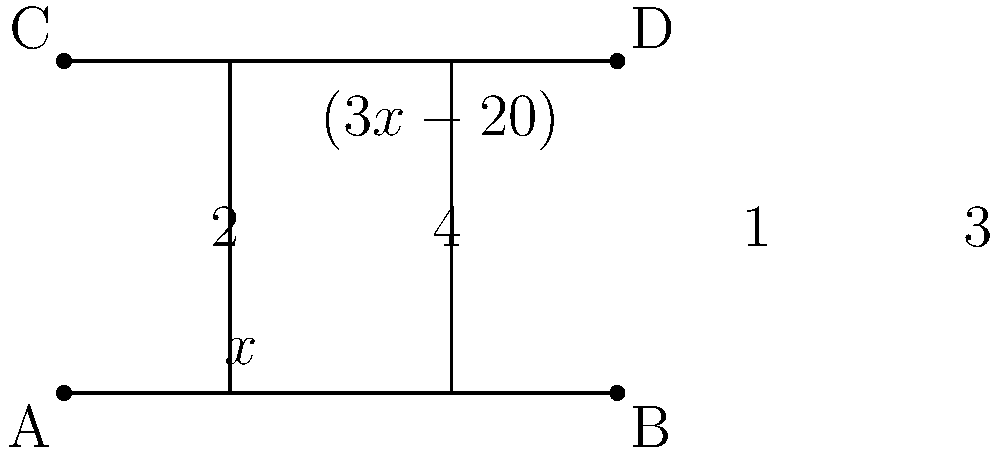In the figure above, lines AB and CD are parallel, and they are intersected by two transversals EF and GH. Given that angle 1 measures $x°$ and angle 4 measures $(3x-20)°$, determine the value of $x$. To solve this problem, let's follow these steps:

1) First, recall that when parallel lines are cut by a transversal, corresponding angles are congruent. This means:
   - Angle 1 = Angle 3
   - Angle 2 = Angle 4

2) We're given that:
   - Angle 1 = $x°$
   - Angle 4 = $(3x-20)°$

3) Since Angle 2 and Angle 4 form a linear pair (they're on the same line), they must sum to 180°:
   Angle 2 + Angle 4 = 180°

4) We know Angle 2 = Angle 1 = $x°$, so we can substitute:
   $x° + (3x-20)° = 180°$

5) Now we can solve this equation:
   $x + 3x - 20 = 180$
   $4x - 20 = 180$
   $4x = 200$
   $x = 50$

6) To verify, let's check:
   - Angle 1 = $50°$
   - Angle 4 = $3(50) - 20 = 130°$
   Indeed, $50° + 130° = 180°$

Therefore, the value of $x$ is 50.
Answer: $x = 50$ 